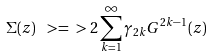Convert formula to latex. <formula><loc_0><loc_0><loc_500><loc_500>\Sigma ( z ) \ > = \ > 2 \sum _ { k = 1 } ^ { \infty } \gamma _ { 2 k } G ^ { 2 k - 1 } ( z )</formula> 